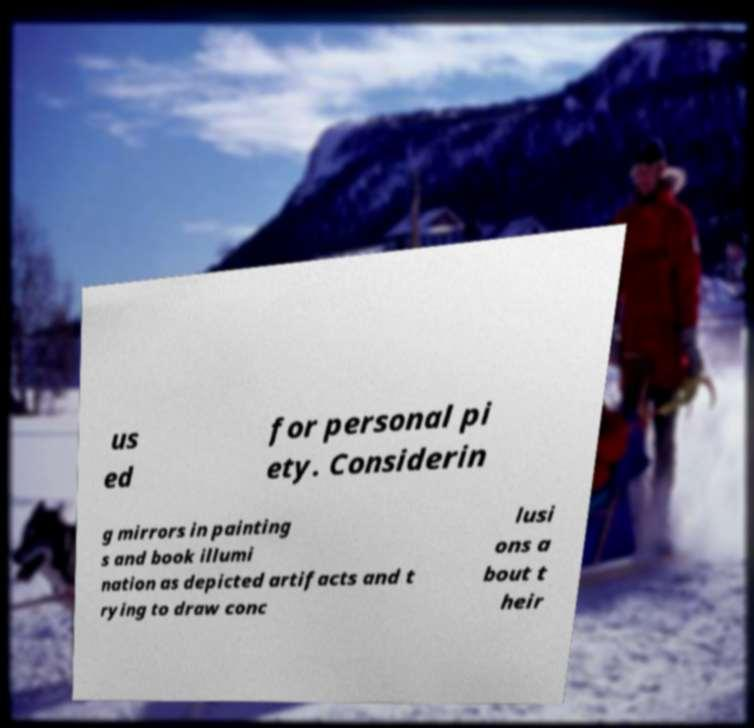Could you extract and type out the text from this image? us ed for personal pi ety. Considerin g mirrors in painting s and book illumi nation as depicted artifacts and t rying to draw conc lusi ons a bout t heir 